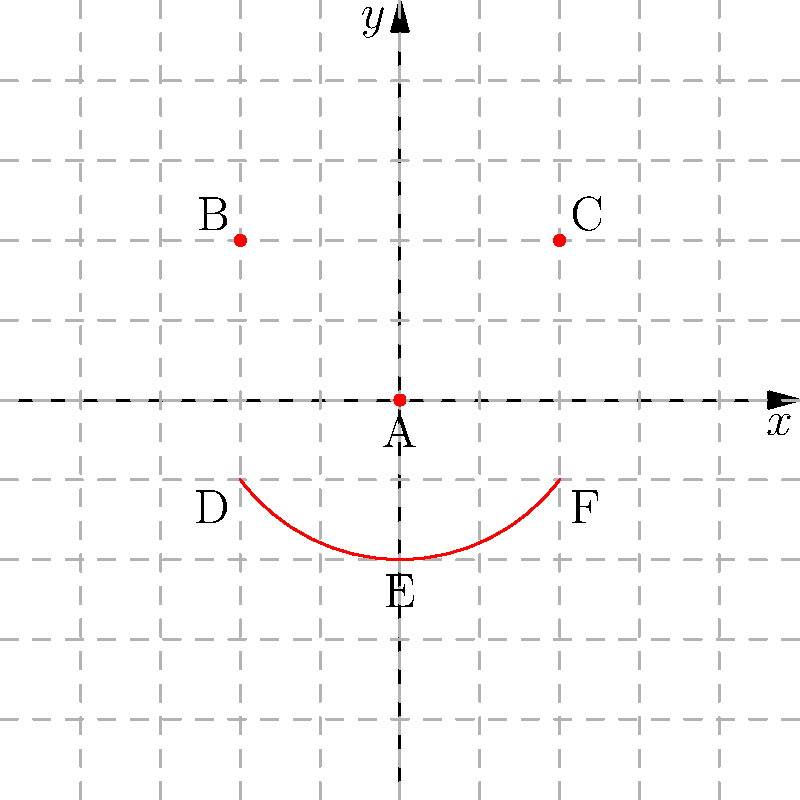Look at the smiley face drawn on the coordinate system. Can you help identify the coordinates of points A, B, and C? Let's identify the coordinates of points A, B, and C step by step:

1. Point A (center of the face):
   - It's located at the origin (where the x and y axes intersect)
   - Its coordinates are (0, 0)

2. Point B (left eye):
   - It's 2 units to the left of the y-axis and 2 units up from the x-axis
   - Its coordinates are (-2, 2)

3. Point C (right eye):
   - It's 2 units to the right of the y-axis and 2 units up from the x-axis
   - Its coordinates are (2, 2)

Remember, coordinates are always written as (x, y), where x is the horizontal distance from the y-axis (negative if left, positive if right) and y is the vertical distance from the x-axis (negative if down, positive if up).
Answer: A(0, 0), B(-2, 2), C(2, 2) 